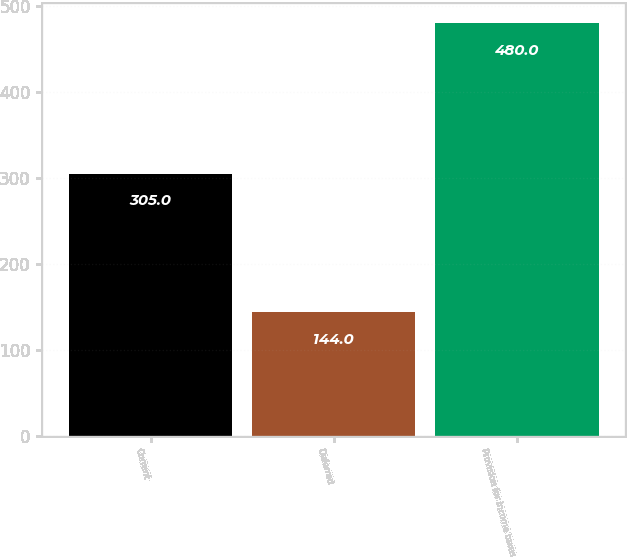Convert chart. <chart><loc_0><loc_0><loc_500><loc_500><bar_chart><fcel>Current<fcel>Deferred<fcel>Provision for income taxes<nl><fcel>305<fcel>144<fcel>480<nl></chart> 